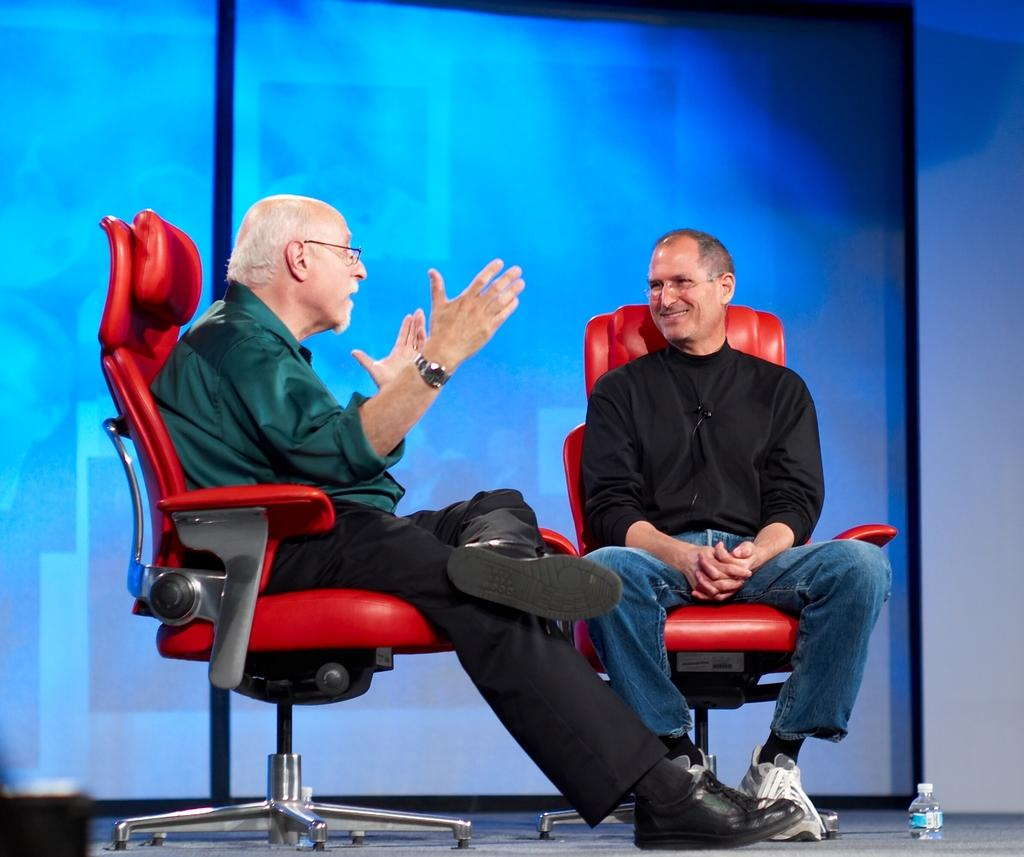How many people are in the image? There are two men in the image. What is the facial expression of one of the men? One of the men is smiling. What are the men doing in the image? Both men are sitting on chairs. What object can be seen in the image? There is a bottle visible in the image. What type of wealth does the father in the image possess? There is no mention of a father or wealth in the image, so it cannot be determined. 